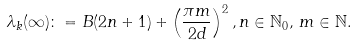Convert formula to latex. <formula><loc_0><loc_0><loc_500><loc_500>\lambda _ { k } ( \infty ) \colon = B ( 2 n + 1 ) + \left ( \frac { \pi m } { 2 d } \right ) ^ { 2 } , n \in \mathbb { N } _ { 0 } , \, m \in \mathbb { N } .</formula> 